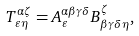<formula> <loc_0><loc_0><loc_500><loc_500>T ^ { \alpha \zeta } _ { \varepsilon \eta } = A ^ { \alpha \beta \gamma \delta } _ { \varepsilon } B ^ { \zeta } _ { \beta \gamma \delta \eta } ,</formula> 